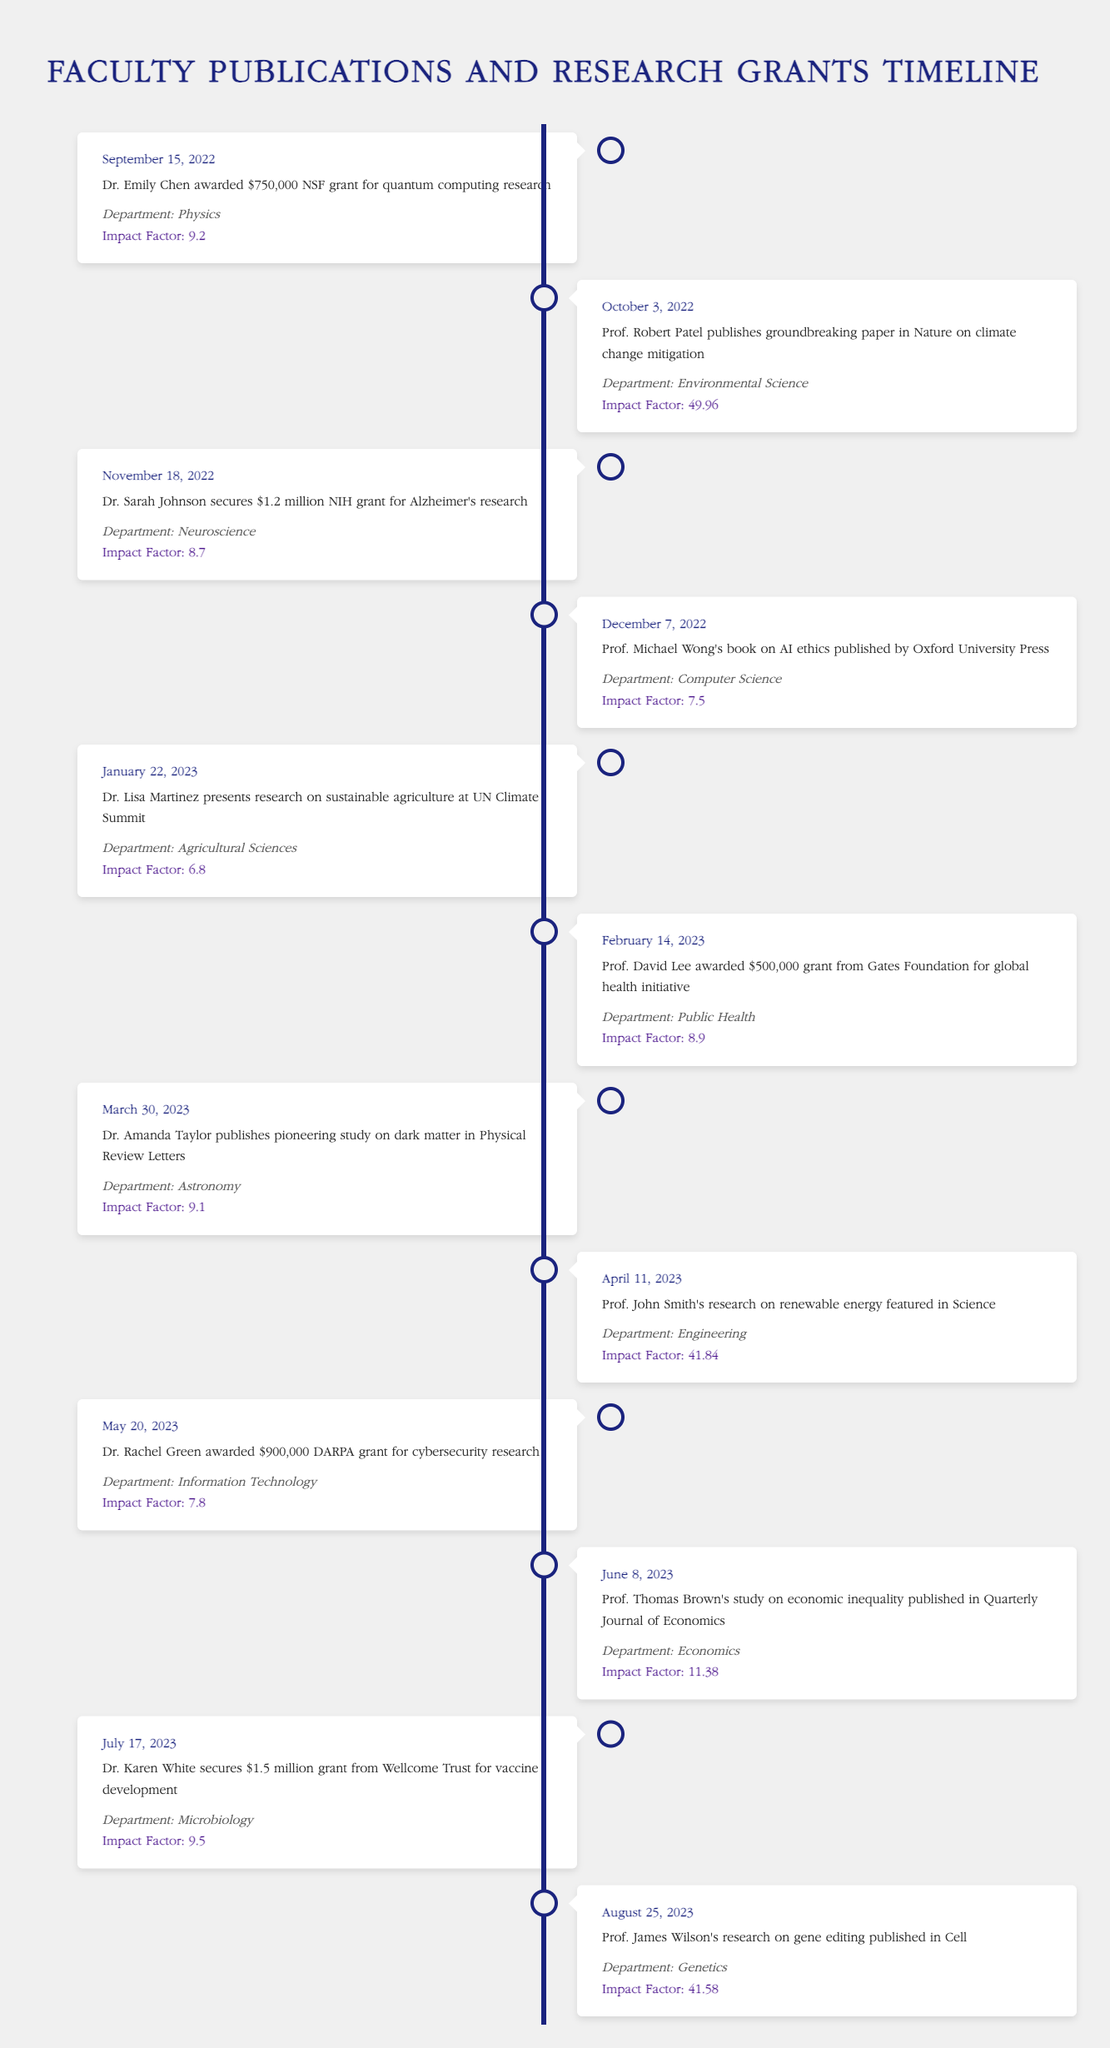What was the highest impact factor of a publication in the timeline? The highest impact factor found in the timeline is 49.96, which corresponds to Prof. Robert Patel's paper published in Nature.
Answer: 49.96 Which department received the largest research grant? Dr. Sarah Johnson secured the largest research grant of $1.2 million from the NIH for Alzheimer's research in the Neuroscience department.
Answer: $1.2 million Is there any publication from the Engineering department in the timeline? Yes, there is a publication from the Engineering department, as Prof. John Smith's research on renewable energy was featured in Science on April 11, 2023.
Answer: Yes How many grants were awarded in total based on the timeline? To find the total number of grants awarded, we count the entries that mention grants: there are five grants awarded (Dr. Emily Chen, Dr. Sarah Johnson, Prof. David Lee, Dr. Rachel Green, and Dr. Karen White).
Answer: 5 What was the average impact factor of the publications listed in the timeline? The impact factors listed are: 9.2, 49.96, 8.7, 7.5, 6.8, 8.9, 9.1, 41.84, 11.38, 9.5, and 41.58. Adding them together gives  8.50, and dividing it by the number of publications (11) results in an average impact factor of approximately 16.68.
Answer: 16.68 Which researcher made a presentation at the UN Climate Summit? Dr. Lisa Martinez presented research on sustainable agriculture at the UN Climate Summit on January 22, 2023.
Answer: Dr. Lisa Martinez Was there a publication about vaccine development? Yes, Dr. Karen White secures a grant for vaccine development, indicating that vaccine-related research is conducted.
Answer: Yes What is the total amount of funding from grants awarded to faculty in the timeline? The total funding from grants can be calculated by summing the amounts: $750,000 (Dr. Chen) + $1,200,000 (Dr. Johnson) + $500,000 (Prof. Lee) + $900,000 (Dr. Green) + $1,500,000 (Dr. White) = $4,850,000.
Answer: $4,850,000 Which research study was published in Physical Review Letters? The pioneering study on dark matter by Dr. Amanda Taylor was published in Physical Review Letters on March 30, 2023.
Answer: Dr. Amanda Taylor's study on dark matter 